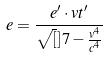<formula> <loc_0><loc_0><loc_500><loc_500>e = \frac { e ^ { \prime } \cdot v t ^ { \prime } } { \sqrt { [ } ] { 7 - \frac { v ^ { 4 } } { c ^ { 4 } } } }</formula> 